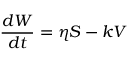<formula> <loc_0><loc_0><loc_500><loc_500>{ \frac { d W } { d t } } = \eta S - k V</formula> 